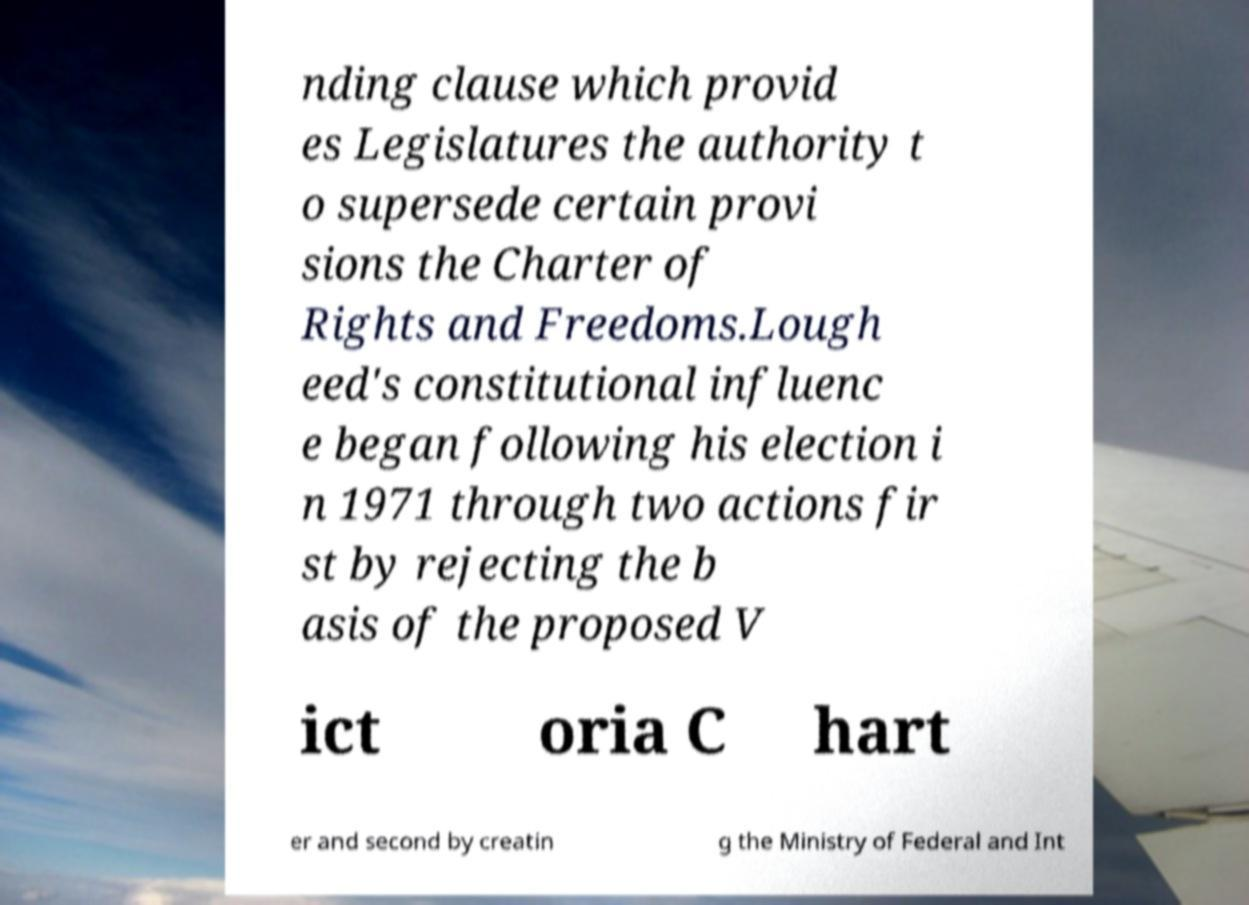Could you assist in decoding the text presented in this image and type it out clearly? nding clause which provid es Legislatures the authority t o supersede certain provi sions the Charter of Rights and Freedoms.Lough eed's constitutional influenc e began following his election i n 1971 through two actions fir st by rejecting the b asis of the proposed V ict oria C hart er and second by creatin g the Ministry of Federal and Int 